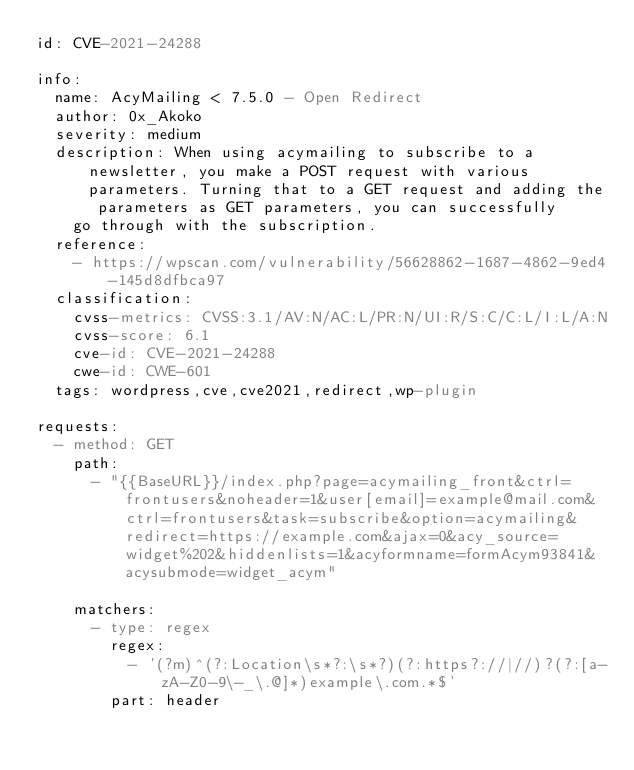<code> <loc_0><loc_0><loc_500><loc_500><_YAML_>id: CVE-2021-24288

info:
  name: AcyMailing < 7.5.0 - Open Redirect
  author: 0x_Akoko
  severity: medium
  description: When using acymailing to subscribe to a newsletter, you make a POST request with various parameters. Turning that to a GET request and adding the parameters as GET parameters, you can successfully
    go through with the subscription.
  reference:
    - https://wpscan.com/vulnerability/56628862-1687-4862-9ed4-145d8dfbca97
  classification:
    cvss-metrics: CVSS:3.1/AV:N/AC:L/PR:N/UI:R/S:C/C:L/I:L/A:N
    cvss-score: 6.1
    cve-id: CVE-2021-24288
    cwe-id: CWE-601
  tags: wordpress,cve,cve2021,redirect,wp-plugin

requests:
  - method: GET
    path:
      - "{{BaseURL}}/index.php?page=acymailing_front&ctrl=frontusers&noheader=1&user[email]=example@mail.com&ctrl=frontusers&task=subscribe&option=acymailing&redirect=https://example.com&ajax=0&acy_source=widget%202&hiddenlists=1&acyformname=formAcym93841&acysubmode=widget_acym"

    matchers:
      - type: regex
        regex:
          - '(?m)^(?:Location\s*?:\s*?)(?:https?://|//)?(?:[a-zA-Z0-9\-_\.@]*)example\.com.*$'
        part: header
</code> 